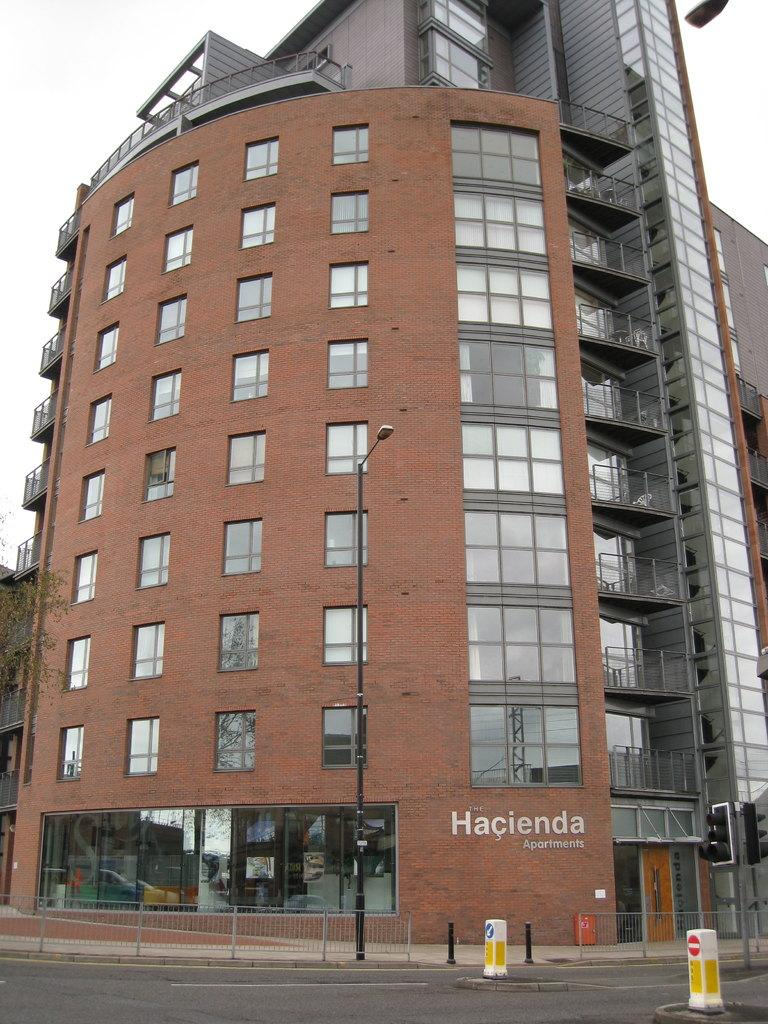Provide a one-sentence caption for the provided image. an apartment complex by the name of 'hacienda apartments'. 